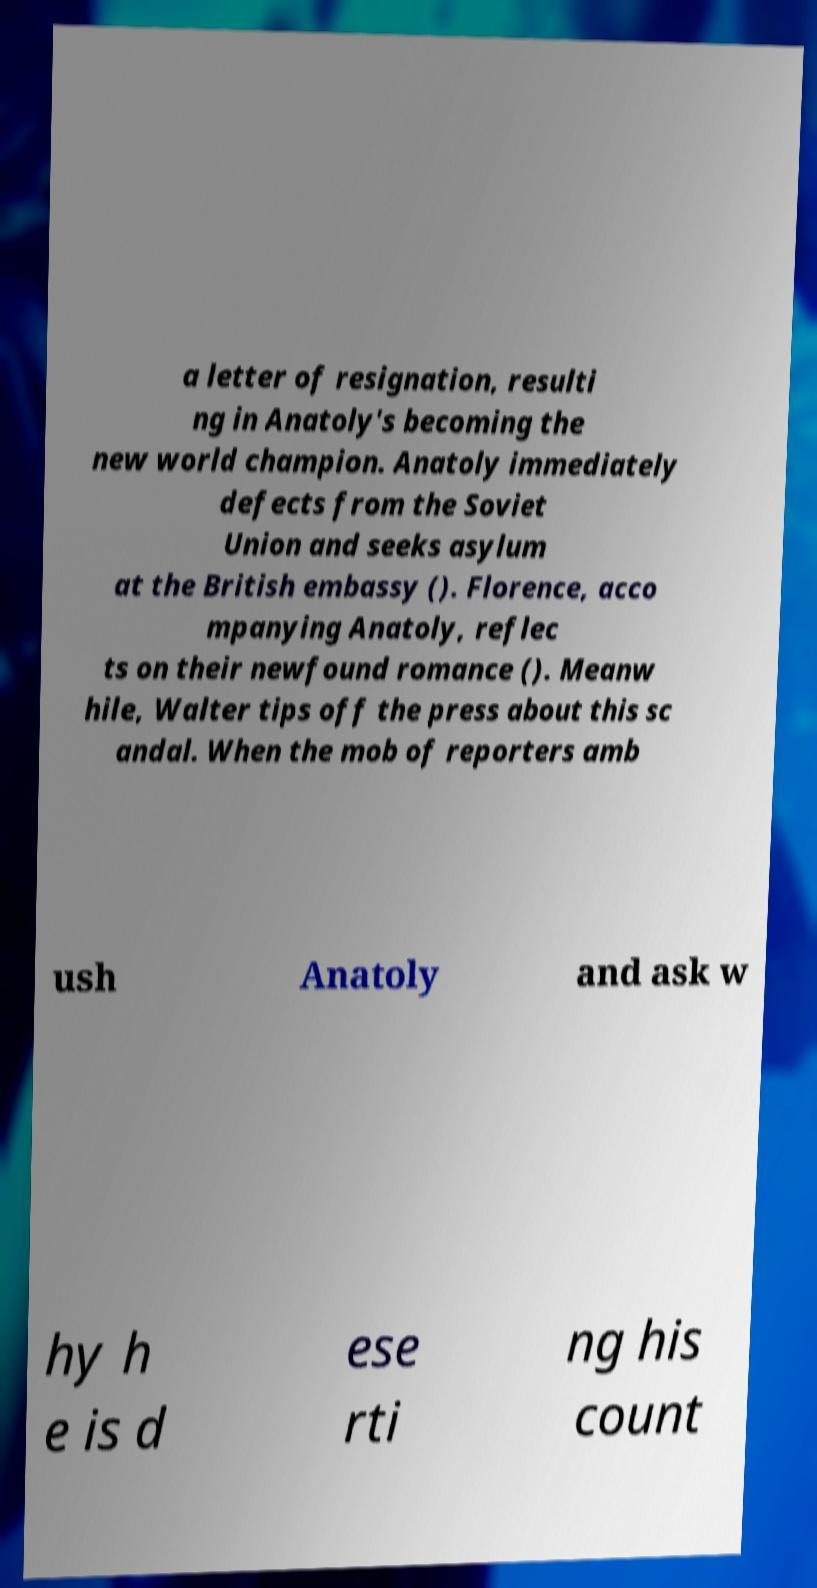Could you extract and type out the text from this image? a letter of resignation, resulti ng in Anatoly's becoming the new world champion. Anatoly immediately defects from the Soviet Union and seeks asylum at the British embassy (). Florence, acco mpanying Anatoly, reflec ts on their newfound romance (). Meanw hile, Walter tips off the press about this sc andal. When the mob of reporters amb ush Anatoly and ask w hy h e is d ese rti ng his count 